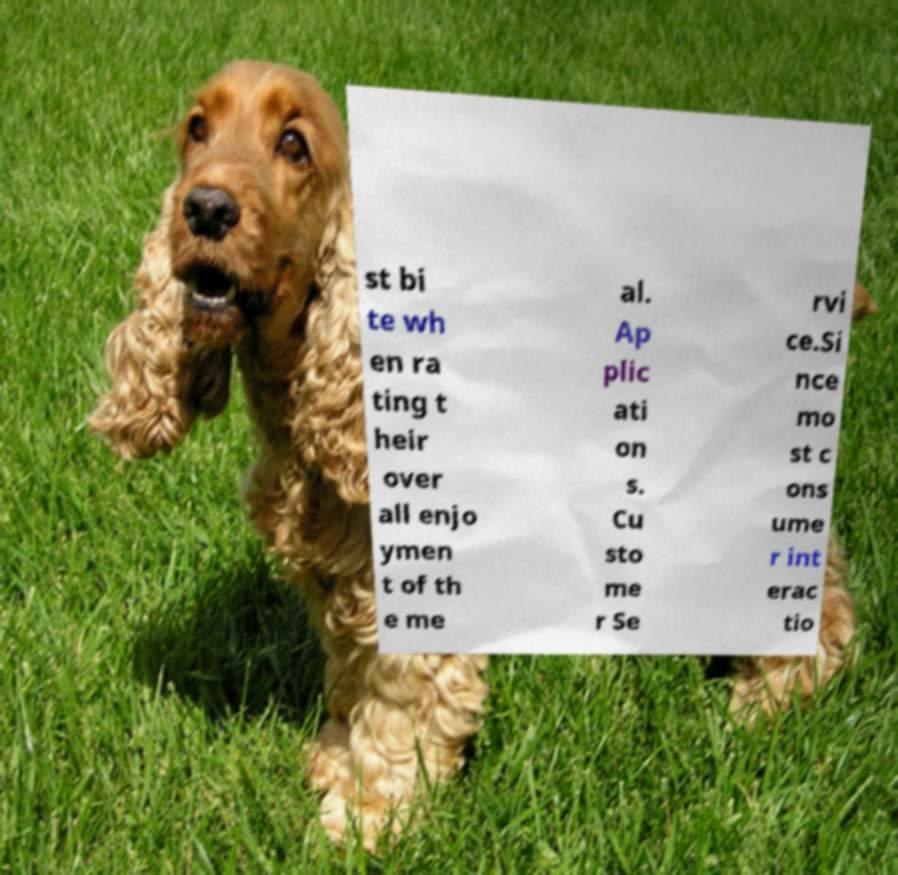For documentation purposes, I need the text within this image transcribed. Could you provide that? st bi te wh en ra ting t heir over all enjo ymen t of th e me al. Ap plic ati on s. Cu sto me r Se rvi ce.Si nce mo st c ons ume r int erac tio 